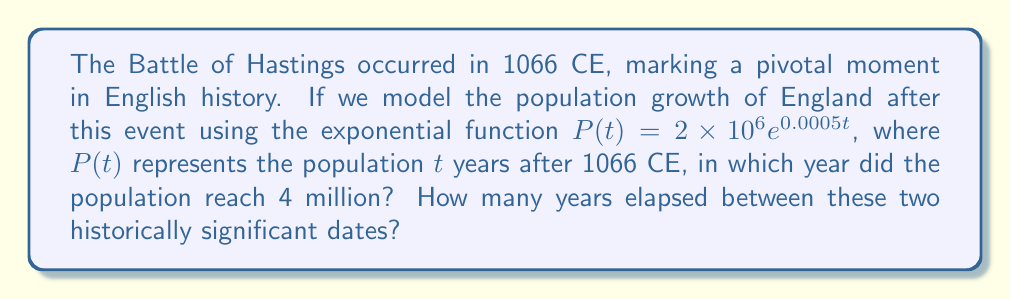Can you solve this math problem? To solve this problem, we need to follow these steps:

1) We start with the given exponential function:
   $P(t) = 2 \times 10^6 e^{0.0005t}$

2) We want to find when $P(t) = 4 \times 10^6$. So, we set up the equation:
   $4 \times 10^6 = 2 \times 10^6 e^{0.0005t}$

3) Divide both sides by $2 \times 10^6$:
   $2 = e^{0.0005t}$

4) Take the natural logarithm of both sides:
   $\ln(2) = 0.0005t$

5) Solve for $t$:
   $t = \frac{\ln(2)}{0.0005} \approx 1386.29$

6) Since $t$ represents years after 1066 CE, we add 1066 to get the actual year:
   $1066 + 1386.29 \approx 2452.29$

7) Rounding down to the nearest year (as we can't have a fractional year), we get 2452 CE.

8) To find the number of years between 1066 CE and 2452 CE:
   $2452 - 1066 = 1386$ years
Answer: 1386 years 